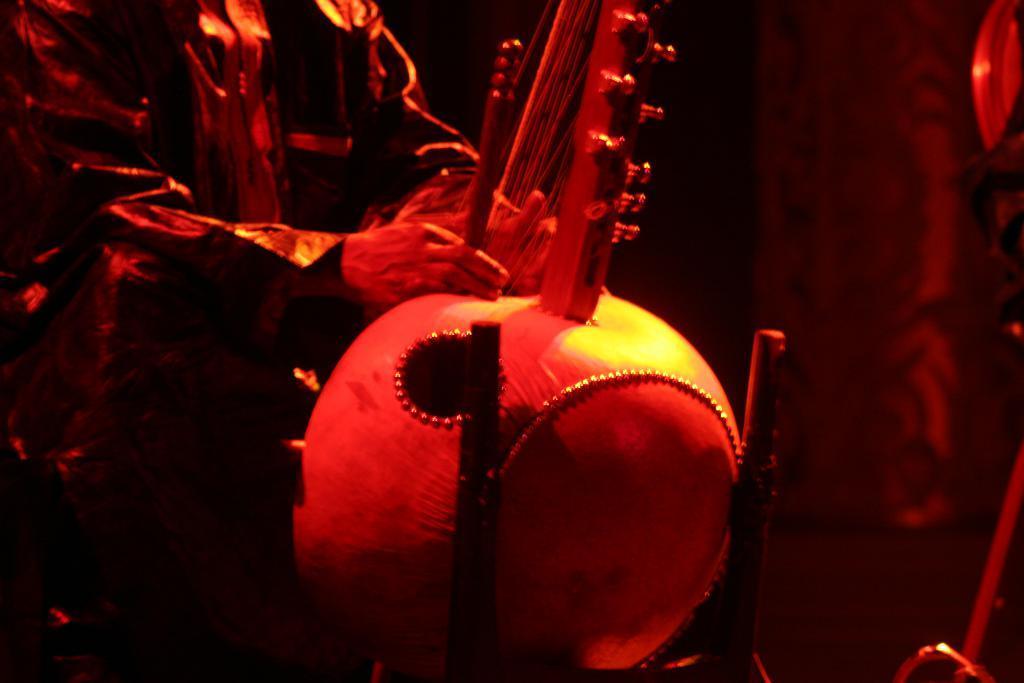Could you give a brief overview of what you see in this image? In this picture we can see a person, some objects and in the background it is dark. 